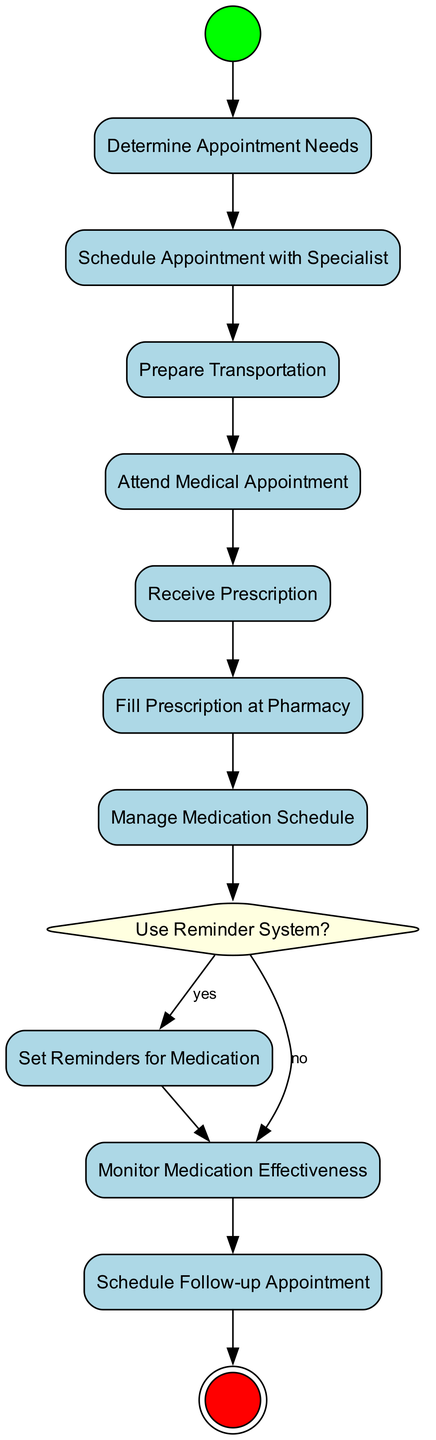What is the first action to take in this diagram? The diagram starts with the "Determine Appointment Needs" action, which indicates the initial step that needs to be taken in the process of managing medical appointments and prescriptions.
Answer: Determine Appointment Needs How many decision nodes are present in the diagram? There is one decision node labeled "Use Reminder System?" which offers a decision point in the workflow of handling prescriptions and medication management.
Answer: 1 What action follows "Attend Medical Appointment"? After "Attend Medical Appointment," the next action is "Receive Prescription," indicating what should happen next following the appointment.
Answer: Receive Prescription Which action is taken if the answer to the decision "Use Reminder System?" is no? If the answer is no, the flow proceeds to "Monitor Medication Effectiveness," which continues the medication management process without setting reminders.
Answer: Monitor Medication Effectiveness List the actions that must be completed before managing the medication schedule. The actions that must be completed before managing the medication schedule are "Fill Prescription at Pharmacy," which comes directly after "Receive Prescription." Therefore, "Receive Prescription" and "Fill Prescription at Pharmacy" must be completed before moving on to "Manage Medication Schedule."
Answer: Fill Prescription at Pharmacy What are the last two actions in the diagram? The last two actions before reaching the end of the diagram are "Monitor Medication Effectiveness" followed by "Schedule Follow-up Appointment," which indicates the final steps in the overall medical management process.
Answer: Monitor Medication Effectiveness, Schedule Follow-up Appointment 